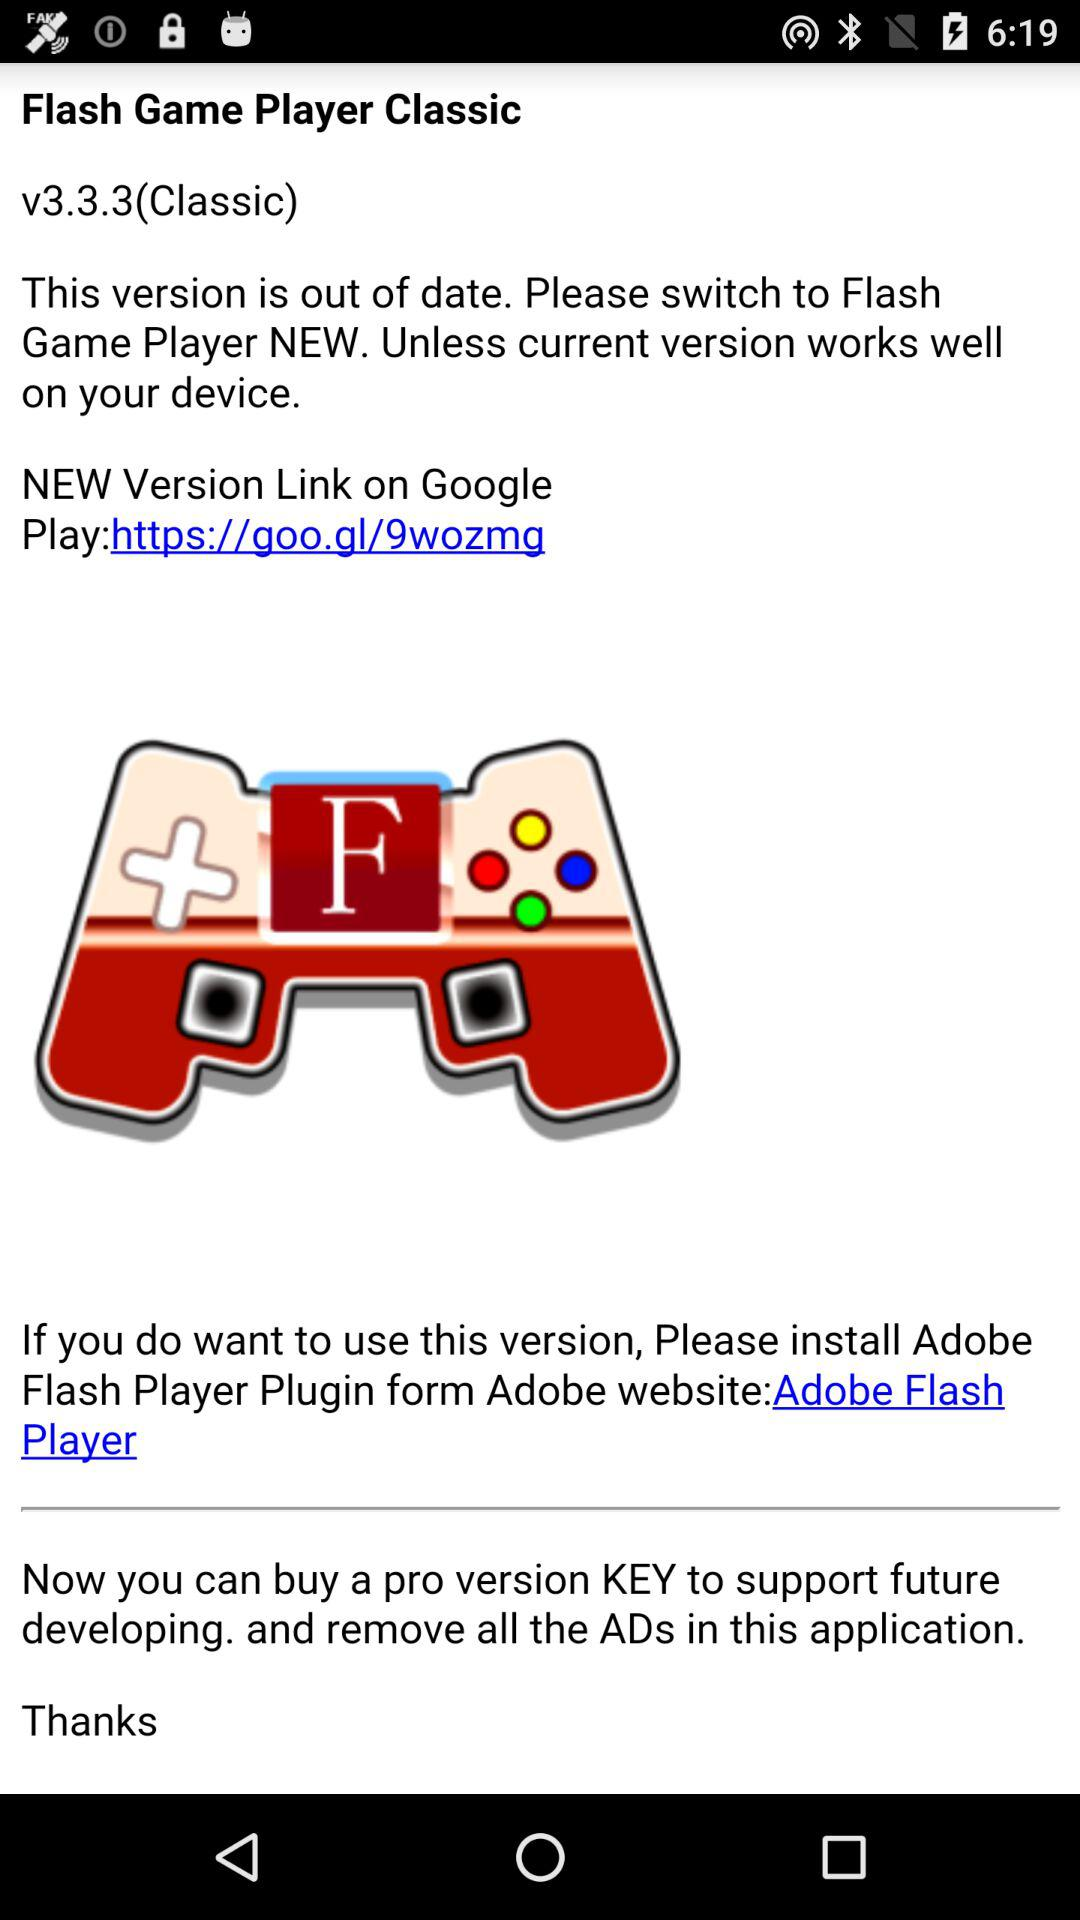What is the new version link on Google? The link is "https://goo.gl/9wozmg". 